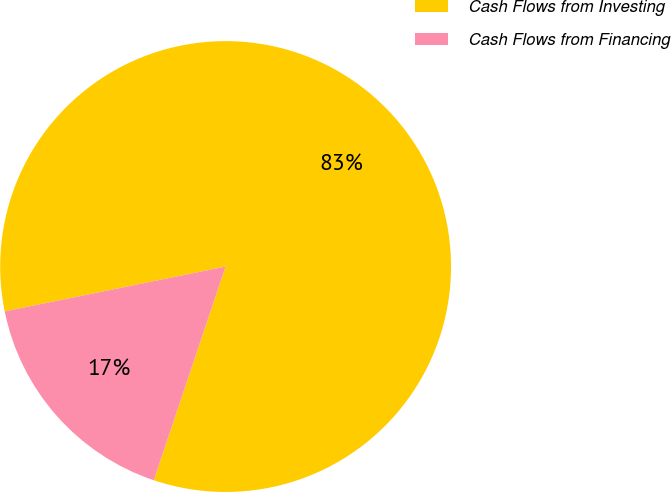<chart> <loc_0><loc_0><loc_500><loc_500><pie_chart><fcel>Cash Flows from Investing<fcel>Cash Flows from Financing<nl><fcel>83.35%<fcel>16.65%<nl></chart> 